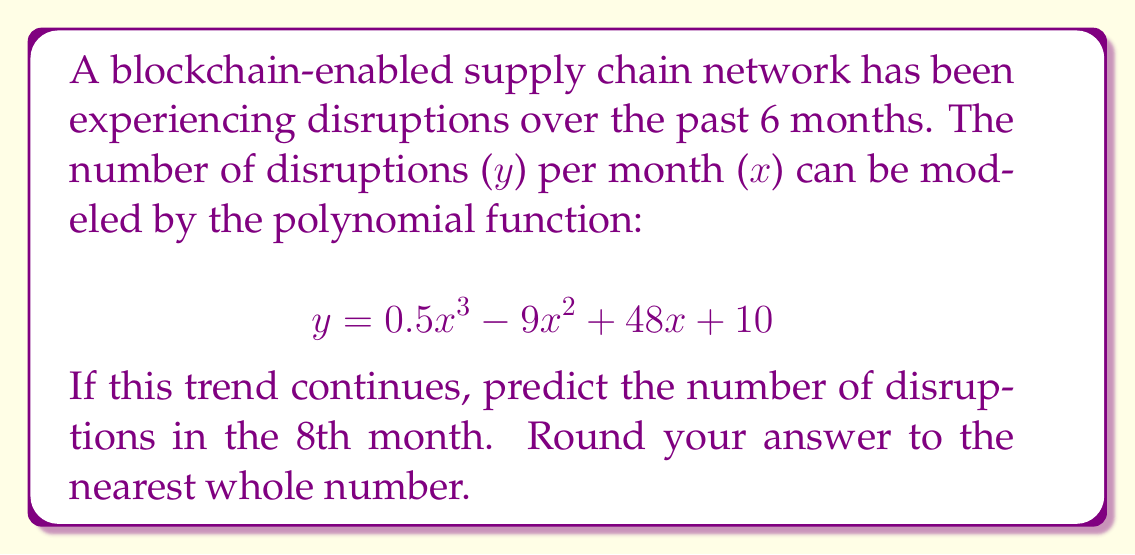Help me with this question. To solve this problem, we need to follow these steps:

1. Identify the given polynomial function:
   $$y = 0.5x^3 - 9x^2 + 48x + 10$$

2. Substitute x = 8 (for the 8th month) into the function:
   $$y = 0.5(8)^3 - 9(8)^2 + 48(8) + 10$$

3. Evaluate the expression:
   $$y = 0.5(512) - 9(64) + 48(8) + 10$$
   $$y = 256 - 576 + 384 + 10$$

4. Perform the arithmetic:
   $$y = 74$$

5. Round to the nearest whole number:
   The result is already a whole number, so no rounding is necessary.

Therefore, based on the polynomial trend analysis, we predict 74 disruptions in the 8th month of the blockchain-enabled supply chain network.
Answer: 74 disruptions 